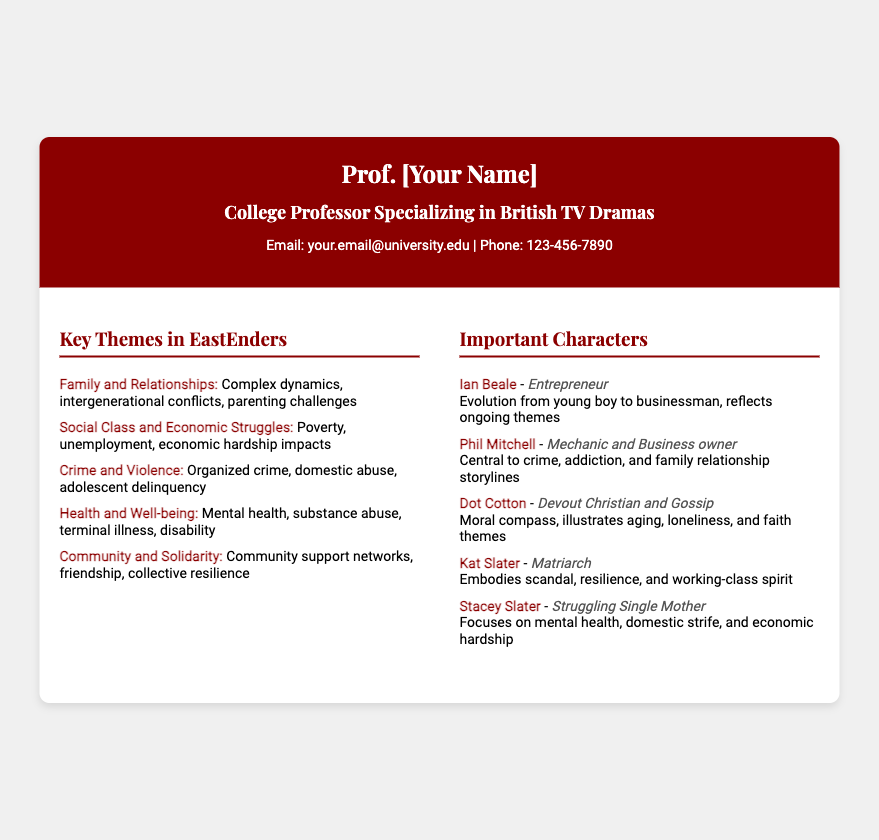What is the name of the professor? The professor's name is provided in the header of the card.
Answer: Prof. [Your Name] What is the email address listed on the card? The email address is mentioned in the contact information section.
Answer: your.email@university.edu How many key themes are listed in the document? The number of themes can be counted in the key themes section.
Answer: 5 Who is described as a struggling single mother? The character focusing on mental health and economic hardship is identified in the characters section.
Answer: Stacey Slater What role does Phil Mitchell have? Phil Mitchell's role can be found in the important characters section.
Answer: Mechanic and Business owner Which theme encompasses poverty and unemployment? This theme can be found in the key themes section.
Answer: Social Class and Economic Struggles What is the character name associated with the role of a devout Christian? The specific character related to faith is mentioned in the characters section.
Answer: Dot Cotton How is Kat Slater primarily characterized? The description of Kat Slater explains her role within the community.
Answer: Matriarch Which character reflects themes of aging and loneliness? The character's role hints at these themes in the document.
Answer: Dot Cotton 